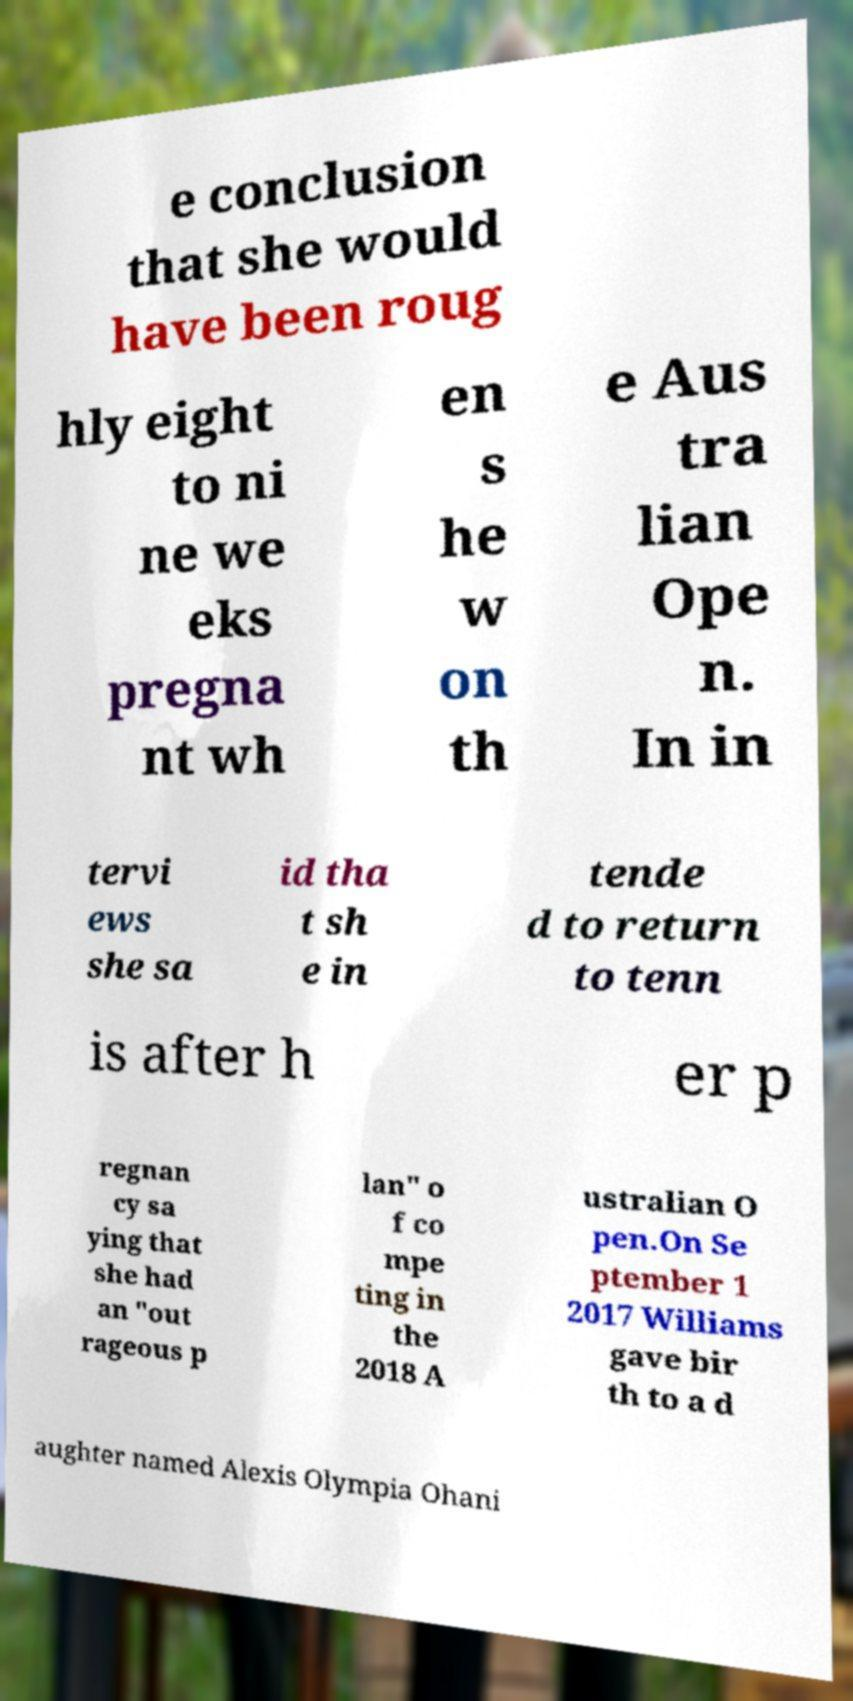Can you read and provide the text displayed in the image?This photo seems to have some interesting text. Can you extract and type it out for me? e conclusion that she would have been roug hly eight to ni ne we eks pregna nt wh en s he w on th e Aus tra lian Ope n. In in tervi ews she sa id tha t sh e in tende d to return to tenn is after h er p regnan cy sa ying that she had an "out rageous p lan" o f co mpe ting in the 2018 A ustralian O pen.On Se ptember 1 2017 Williams gave bir th to a d aughter named Alexis Olympia Ohani 